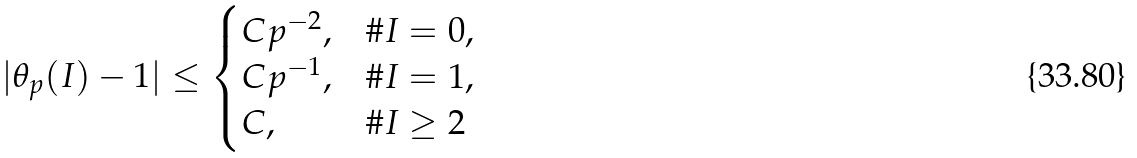<formula> <loc_0><loc_0><loc_500><loc_500>| \theta _ { p } ( I ) - 1 | \leq \begin{cases} C p ^ { - 2 } , & \# I = 0 , \\ C p ^ { - 1 } , & \# I = 1 , \\ C , & \# I \geq 2 \end{cases}</formula> 